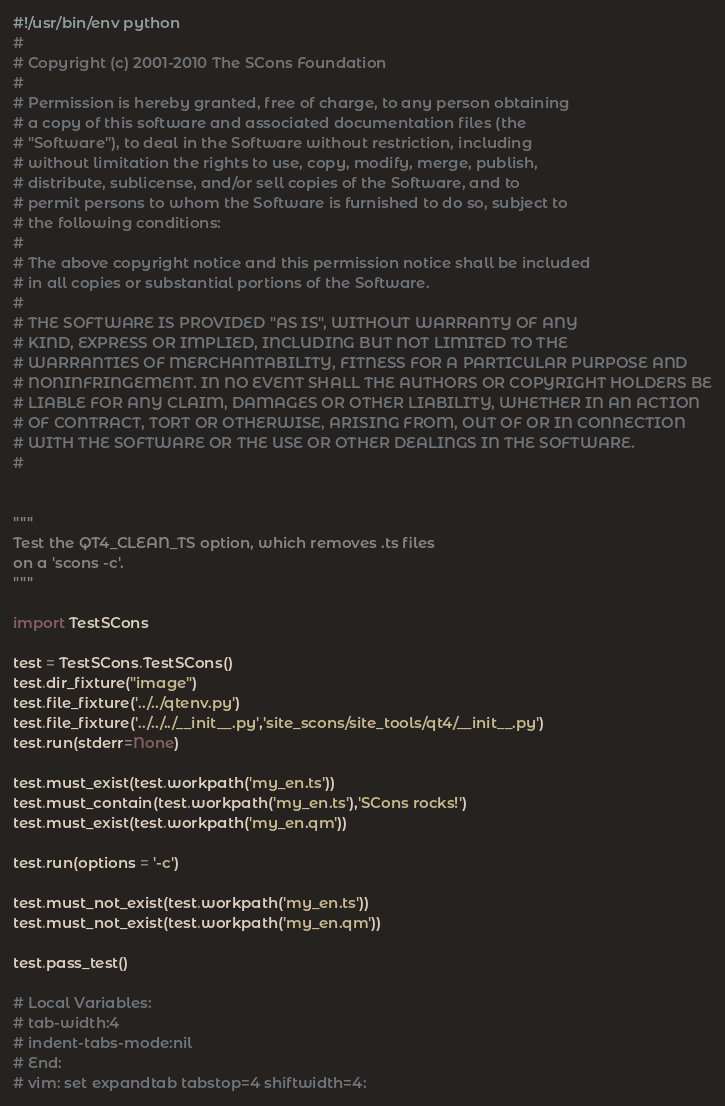Convert code to text. <code><loc_0><loc_0><loc_500><loc_500><_Python_>#!/usr/bin/env python
#
# Copyright (c) 2001-2010 The SCons Foundation
#
# Permission is hereby granted, free of charge, to any person obtaining
# a copy of this software and associated documentation files (the
# "Software"), to deal in the Software without restriction, including
# without limitation the rights to use, copy, modify, merge, publish,
# distribute, sublicense, and/or sell copies of the Software, and to
# permit persons to whom the Software is furnished to do so, subject to
# the following conditions:
#
# The above copyright notice and this permission notice shall be included
# in all copies or substantial portions of the Software.
#
# THE SOFTWARE IS PROVIDED "AS IS", WITHOUT WARRANTY OF ANY
# KIND, EXPRESS OR IMPLIED, INCLUDING BUT NOT LIMITED TO THE
# WARRANTIES OF MERCHANTABILITY, FITNESS FOR A PARTICULAR PURPOSE AND
# NONINFRINGEMENT. IN NO EVENT SHALL THE AUTHORS OR COPYRIGHT HOLDERS BE
# LIABLE FOR ANY CLAIM, DAMAGES OR OTHER LIABILITY, WHETHER IN AN ACTION
# OF CONTRACT, TORT OR OTHERWISE, ARISING FROM, OUT OF OR IN CONNECTION
# WITH THE SOFTWARE OR THE USE OR OTHER DEALINGS IN THE SOFTWARE.
#


"""
Test the QT4_CLEAN_TS option, which removes .ts files
on a 'scons -c'.
"""

import TestSCons

test = TestSCons.TestSCons()
test.dir_fixture("image")
test.file_fixture('../../qtenv.py')
test.file_fixture('../../../__init__.py','site_scons/site_tools/qt4/__init__.py')
test.run(stderr=None)

test.must_exist(test.workpath('my_en.ts'))
test.must_contain(test.workpath('my_en.ts'),'SCons rocks!')
test.must_exist(test.workpath('my_en.qm'))

test.run(options = '-c')

test.must_not_exist(test.workpath('my_en.ts'))
test.must_not_exist(test.workpath('my_en.qm'))

test.pass_test()

# Local Variables:
# tab-width:4
# indent-tabs-mode:nil
# End:
# vim: set expandtab tabstop=4 shiftwidth=4:
</code> 